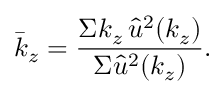<formula> <loc_0><loc_0><loc_500><loc_500>\bar { k } _ { z } = \frac { \Sigma k _ { z } \, \hat { u } ^ { 2 } ( k _ { z } ) } { \Sigma \hat { u } ^ { 2 } ( k _ { z } ) } .</formula> 